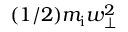<formula> <loc_0><loc_0><loc_500><loc_500>( 1 / 2 ) m _ { i } w _ { \perp } ^ { 2 }</formula> 